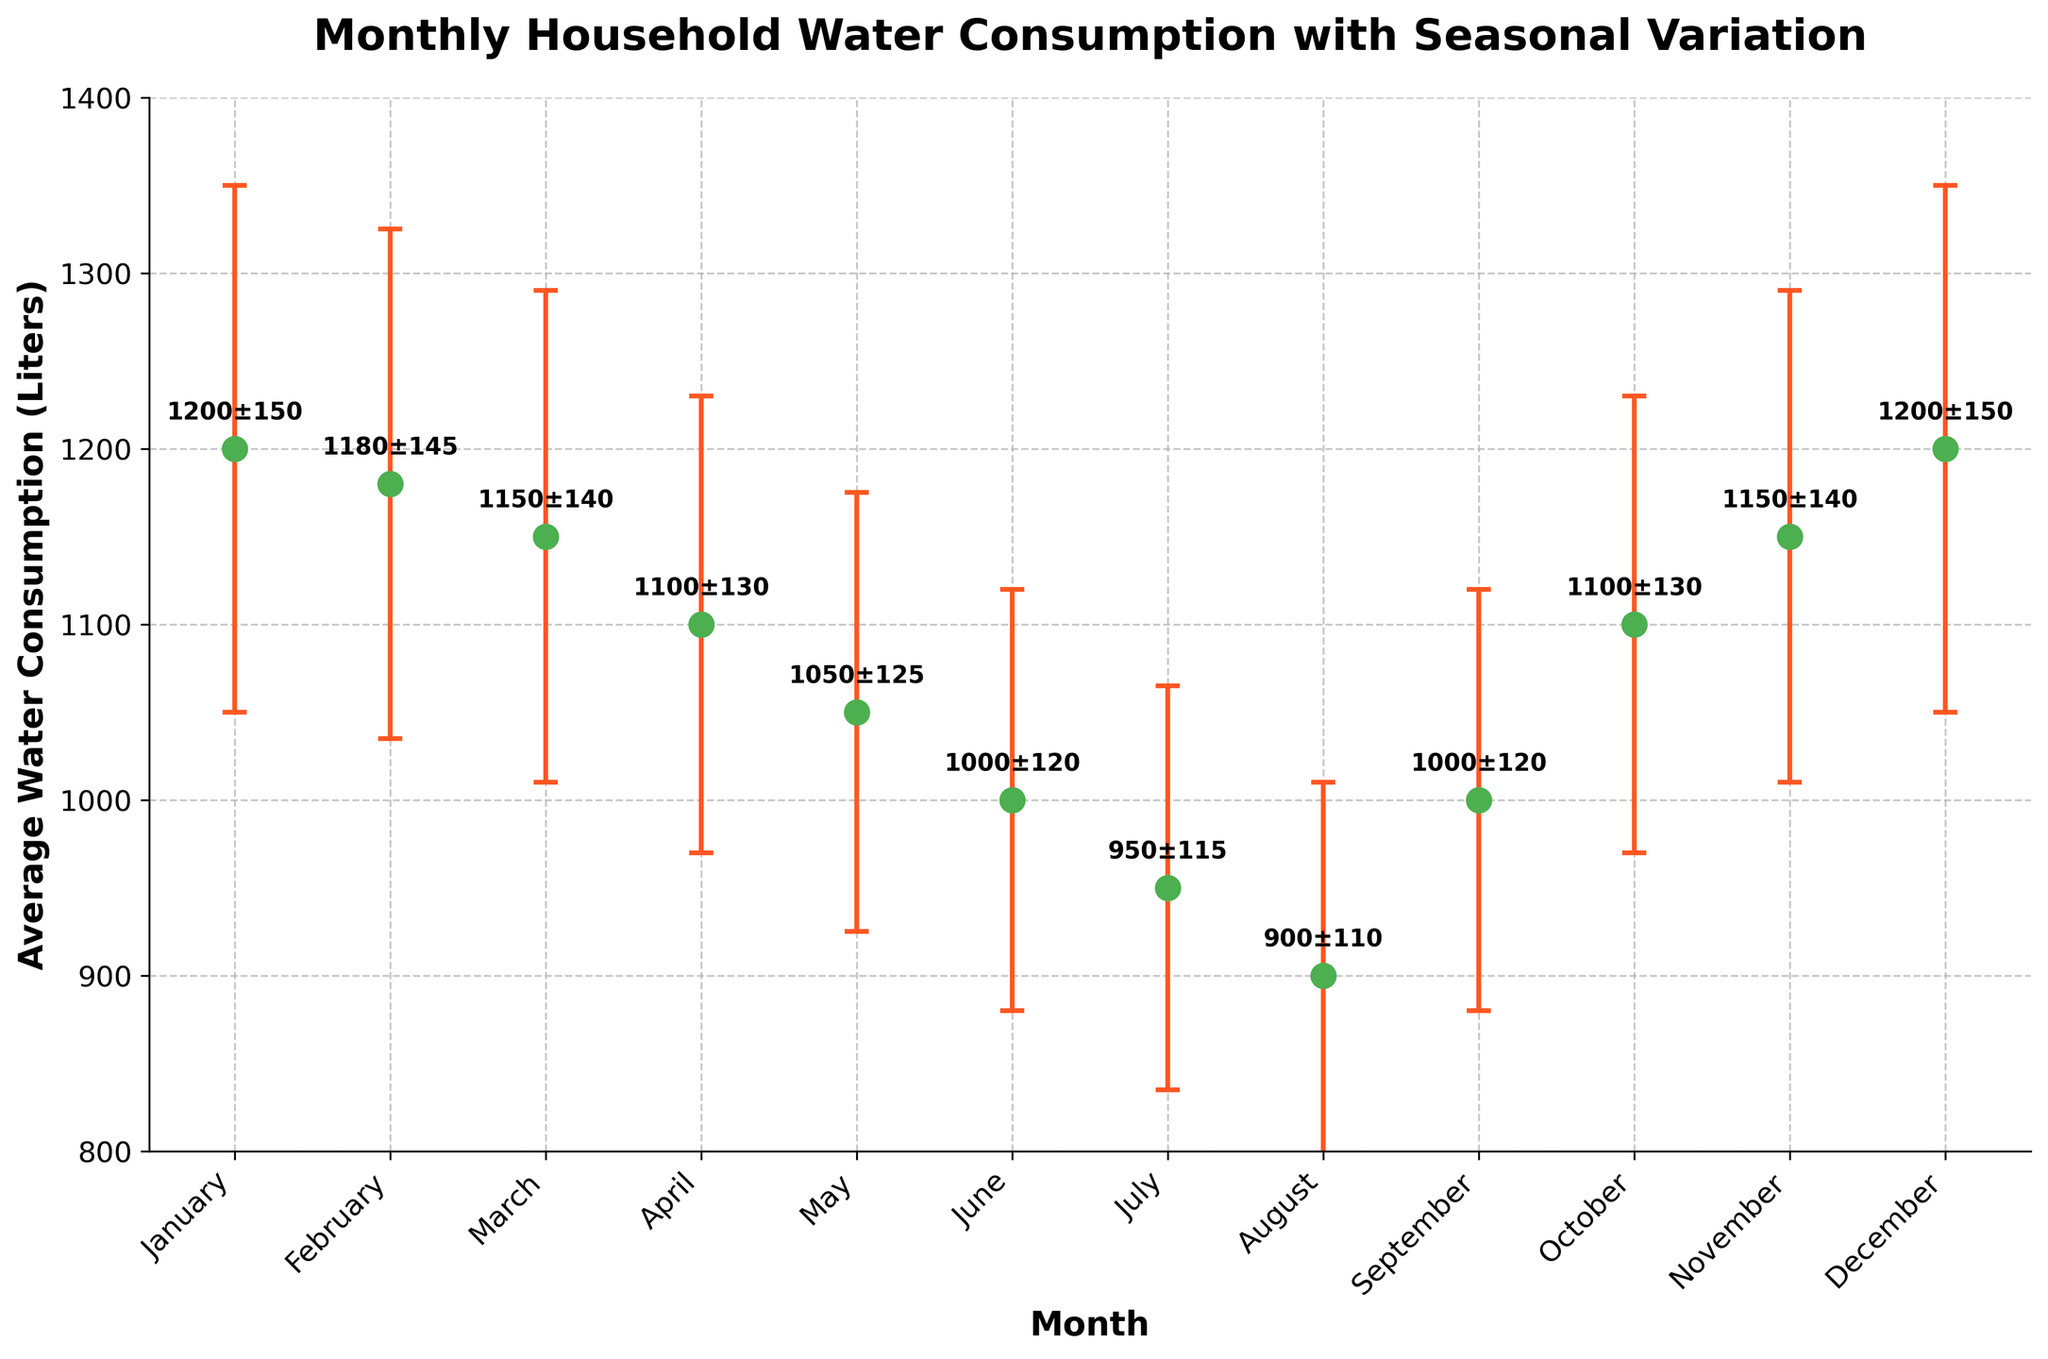What is the title of the figure? The title is displayed at the top of the figure. It summarizes the main topic of the plot.
Answer: Monthly Household Water Consumption with Seasonal Variation What is the average water consumption in August? Locate the August point on the x-axis and read the corresponding value on the y-axis.
Answer: 900 liters What is the standard deviation for January? The standard deviation for each month is represented by the error bars. For January, find the length of the error bar. Additionally, it can be found in the annotation.
Answer: 150 liters During which month is the water consumption the lowest? Identify and compare the average water consumption for each month to find the lowest value.
Answer: August What is the difference in average water consumption between May and July? Find the average consumption for both May and July and subtract the values. For May, it is 1050 liters, and for July, it is 950 liters. Calculate 1050 - 950.
Answer: 100 liters How does the water consumption vary between winter (December to February) and summer (June to August)? Sum the average water consumption for December, January, and February to get the winter total. Do the same for June, July, and August for the summer total. Then compare the two sums.
Answer: Winter: 3580 liters, Summer: 2850 liters; Winter consumption is higher Which month has the highest uncertainty in water consumption? The month with the longest error bar or highest standard deviation value indicates the highest uncertainty.
Answer: January and December How much does the water consumption change from June to September? Find the average consumption for June (1000 liters) and September (1000 liters) and calculate the difference.
Answer: 0 liters Which months have an average consumption of 1100 liters? Identify the months where the y-axis value corresponds to 1100 liters.
Answer: April and October How much higher is the average consumption in March than in July? Find the average consumption for March (1150 liters) and July (950 liters) and calculate the difference.
Answer: 200 liters 